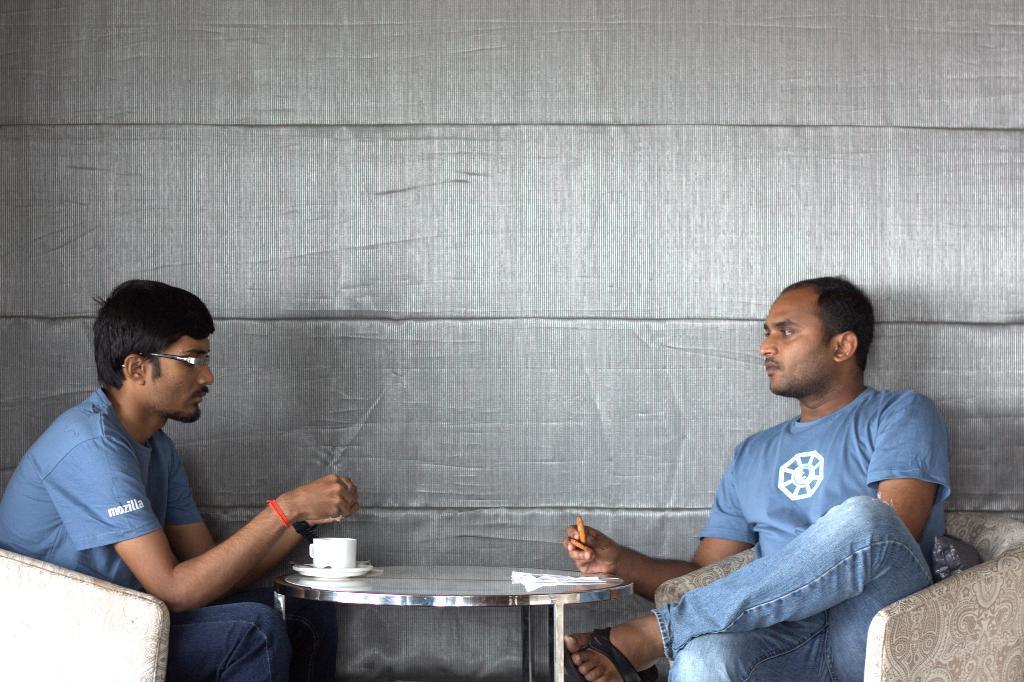How would you summarize this image in a sentence or two? There are two people in the image. They wore blue color T-shirt and trouser. They were sitting on the chairs. This is a table with a tissue paper,a cup and saucer on it. One person is holding biscuits on his hand. At background this looks like a wall which is grey in color. 